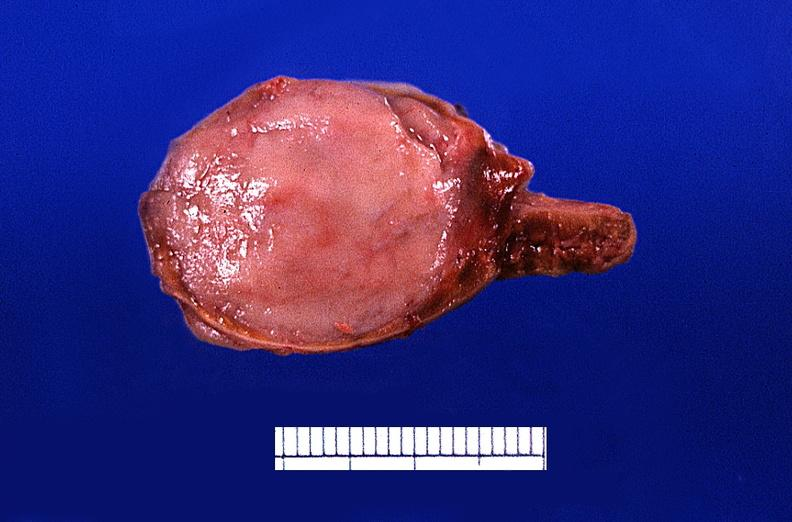does peritoneal fluid show adrenal medullary tumor?
Answer the question using a single word or phrase. No 